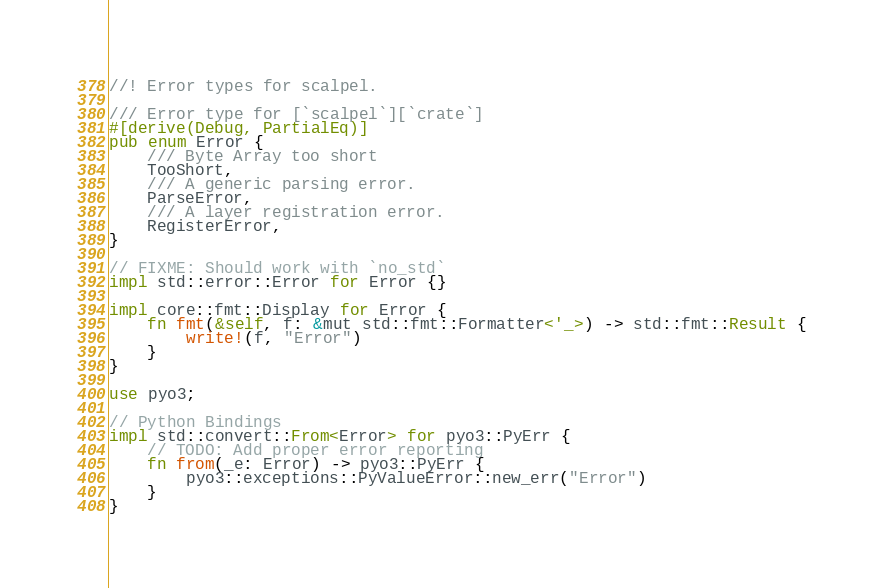<code> <loc_0><loc_0><loc_500><loc_500><_Rust_>//! Error types for scalpel.

/// Error type for [`scalpel`][`crate`]
#[derive(Debug, PartialEq)]
pub enum Error {
    /// Byte Array too short
    TooShort,
    /// A generic parsing error.
    ParseError,
    /// A layer registration error.
    RegisterError,
}

// FIXME: Should work with `no_std`
impl std::error::Error for Error {}

impl core::fmt::Display for Error {
    fn fmt(&self, f: &mut std::fmt::Formatter<'_>) -> std::fmt::Result {
        write!(f, "Error")
    }
}

use pyo3;

// Python Bindings
impl std::convert::From<Error> for pyo3::PyErr {
    // TODO: Add proper error reporting
    fn from(_e: Error) -> pyo3::PyErr {
        pyo3::exceptions::PyValueError::new_err("Error")
    }
}
</code> 